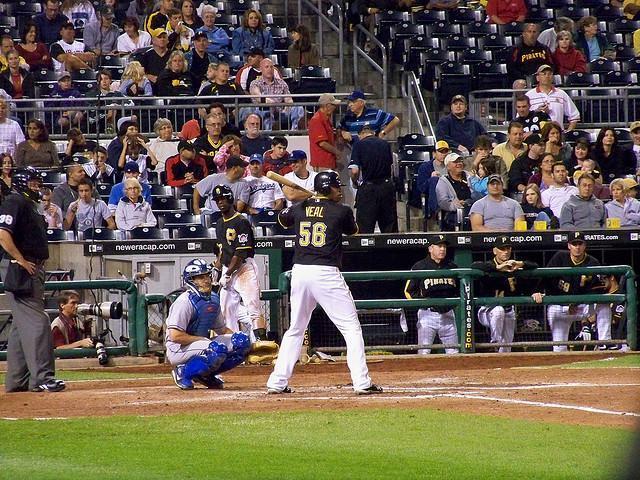How many people are there?
Give a very brief answer. 4. 